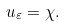<formula> <loc_0><loc_0><loc_500><loc_500>u _ { \varepsilon } = \chi .</formula> 